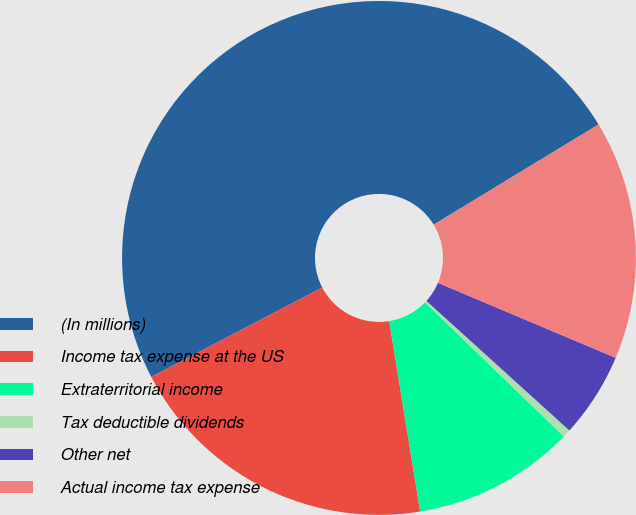<chart> <loc_0><loc_0><loc_500><loc_500><pie_chart><fcel>(In millions)<fcel>Income tax expense at the US<fcel>Extraterritorial income<fcel>Tax deductible dividends<fcel>Other net<fcel>Actual income tax expense<nl><fcel>48.97%<fcel>19.9%<fcel>10.21%<fcel>0.51%<fcel>5.36%<fcel>15.05%<nl></chart> 